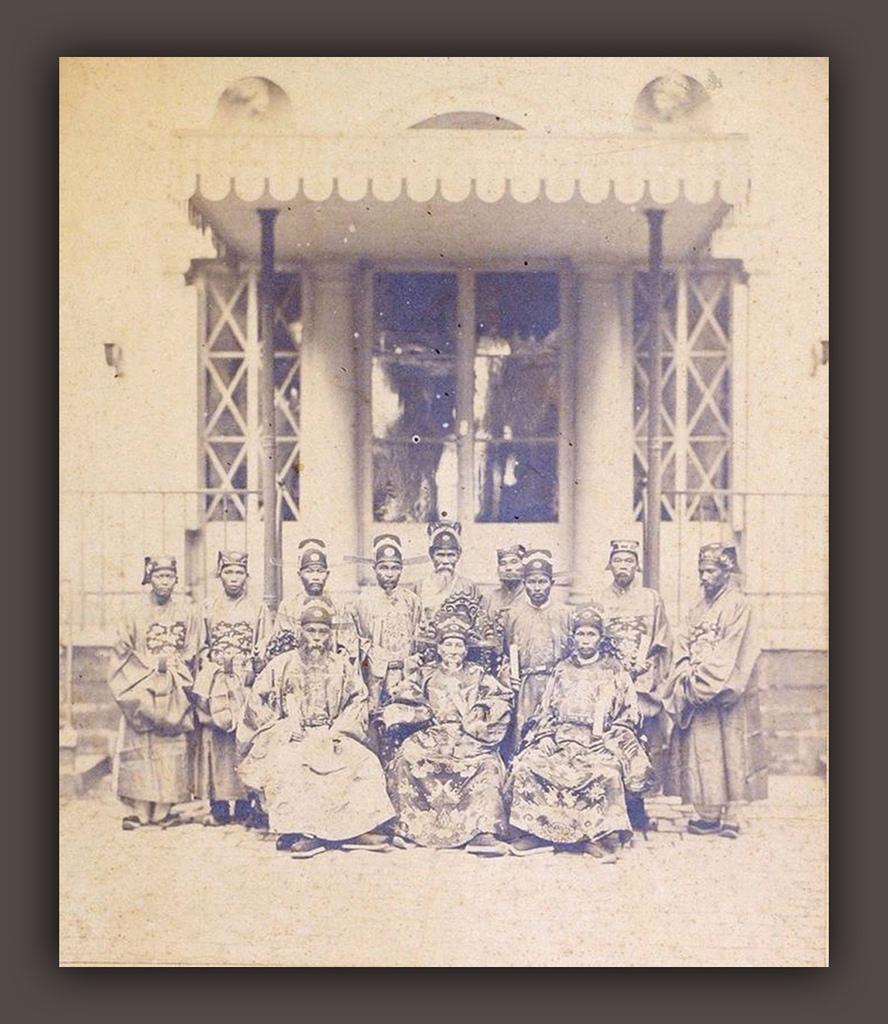Can you describe this image briefly? This is a black and white picture. In front of the picture, we see three people are sitting on the chair. Behind them, we see the people are standing. They might be posing for the photo. In the background, we see a building in white color. It has the glass windows and a glass door. We see the poles and the pillars. This picture might be a photo frame. 